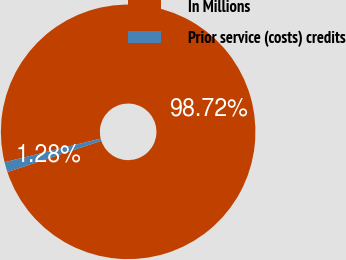Convert chart. <chart><loc_0><loc_0><loc_500><loc_500><pie_chart><fcel>In Millions<fcel>Prior service (costs) credits<nl><fcel>98.72%<fcel>1.28%<nl></chart> 